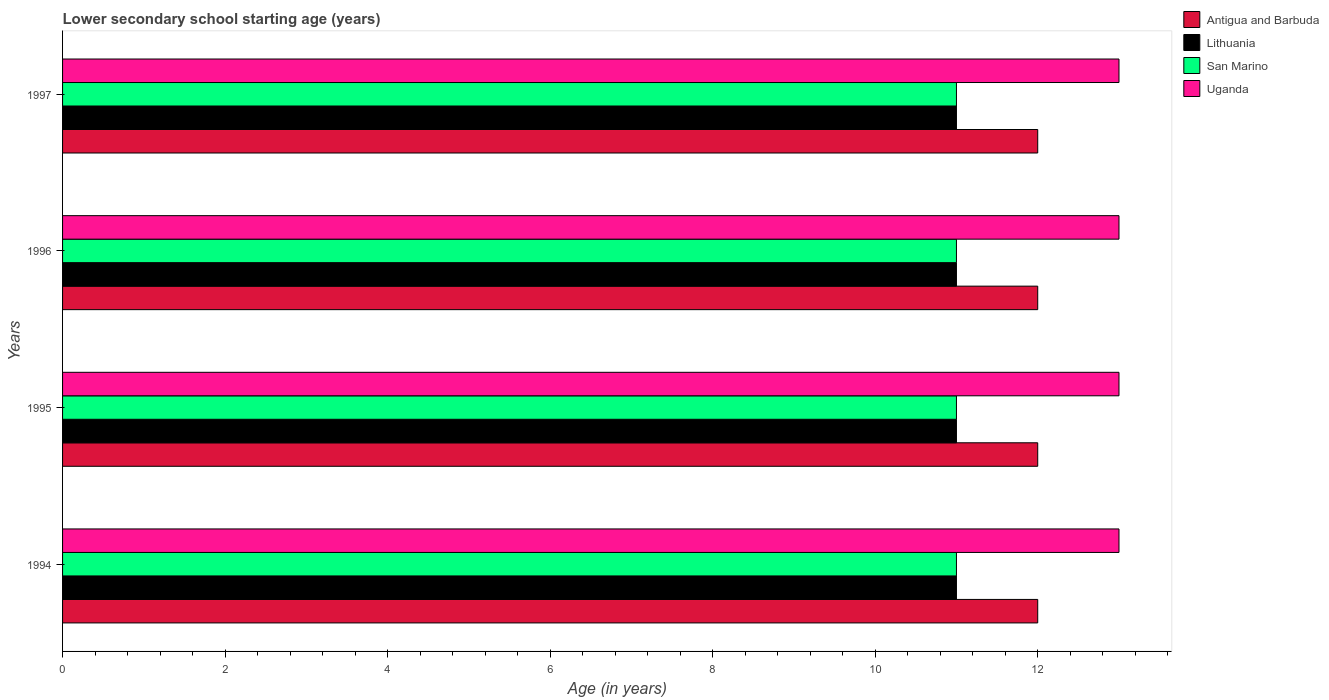How many different coloured bars are there?
Offer a terse response. 4. Are the number of bars on each tick of the Y-axis equal?
Provide a short and direct response. Yes. In how many cases, is the number of bars for a given year not equal to the number of legend labels?
Provide a short and direct response. 0. What is the lower secondary school starting age of children in Uganda in 1995?
Give a very brief answer. 13. Across all years, what is the maximum lower secondary school starting age of children in San Marino?
Provide a succinct answer. 11. Across all years, what is the minimum lower secondary school starting age of children in San Marino?
Provide a succinct answer. 11. What is the total lower secondary school starting age of children in Antigua and Barbuda in the graph?
Make the answer very short. 48. What is the difference between the lower secondary school starting age of children in Uganda in 1997 and the lower secondary school starting age of children in Antigua and Barbuda in 1995?
Offer a very short reply. 1. What is the average lower secondary school starting age of children in Lithuania per year?
Your answer should be very brief. 11. In the year 1994, what is the difference between the lower secondary school starting age of children in San Marino and lower secondary school starting age of children in Antigua and Barbuda?
Provide a succinct answer. -1. In how many years, is the lower secondary school starting age of children in Lithuania greater than 11.6 years?
Offer a very short reply. 0. Is the lower secondary school starting age of children in Lithuania in 1994 less than that in 1997?
Ensure brevity in your answer.  No. Is the difference between the lower secondary school starting age of children in San Marino in 1994 and 1995 greater than the difference between the lower secondary school starting age of children in Antigua and Barbuda in 1994 and 1995?
Give a very brief answer. No. Is the sum of the lower secondary school starting age of children in San Marino in 1995 and 1996 greater than the maximum lower secondary school starting age of children in Uganda across all years?
Make the answer very short. Yes. What does the 1st bar from the top in 1994 represents?
Make the answer very short. Uganda. What does the 3rd bar from the bottom in 1996 represents?
Offer a terse response. San Marino. How many bars are there?
Offer a very short reply. 16. How many years are there in the graph?
Offer a terse response. 4. Are the values on the major ticks of X-axis written in scientific E-notation?
Your answer should be compact. No. Does the graph contain any zero values?
Your response must be concise. No. Where does the legend appear in the graph?
Your answer should be very brief. Top right. What is the title of the graph?
Offer a terse response. Lower secondary school starting age (years). What is the label or title of the X-axis?
Give a very brief answer. Age (in years). What is the Age (in years) of Antigua and Barbuda in 1994?
Your answer should be very brief. 12. What is the Age (in years) of Lithuania in 1994?
Keep it short and to the point. 11. What is the Age (in years) in Uganda in 1995?
Offer a very short reply. 13. What is the Age (in years) of Uganda in 1996?
Provide a succinct answer. 13. What is the Age (in years) of Antigua and Barbuda in 1997?
Provide a short and direct response. 12. What is the Age (in years) in Lithuania in 1997?
Offer a very short reply. 11. What is the Age (in years) in Uganda in 1997?
Your response must be concise. 13. Across all years, what is the maximum Age (in years) of Lithuania?
Keep it short and to the point. 11. Across all years, what is the maximum Age (in years) of San Marino?
Offer a very short reply. 11. Across all years, what is the minimum Age (in years) in Antigua and Barbuda?
Provide a succinct answer. 12. Across all years, what is the minimum Age (in years) in Lithuania?
Keep it short and to the point. 11. Across all years, what is the minimum Age (in years) of Uganda?
Your response must be concise. 13. What is the total Age (in years) of San Marino in the graph?
Your answer should be very brief. 44. What is the difference between the Age (in years) of Lithuania in 1994 and that in 1995?
Your answer should be very brief. 0. What is the difference between the Age (in years) in Uganda in 1994 and that in 1995?
Your response must be concise. 0. What is the difference between the Age (in years) in Antigua and Barbuda in 1994 and that in 1996?
Your response must be concise. 0. What is the difference between the Age (in years) of Lithuania in 1994 and that in 1996?
Ensure brevity in your answer.  0. What is the difference between the Age (in years) in San Marino in 1994 and that in 1997?
Make the answer very short. 0. What is the difference between the Age (in years) of Lithuania in 1995 and that in 1996?
Keep it short and to the point. 0. What is the difference between the Age (in years) of San Marino in 1995 and that in 1996?
Provide a succinct answer. 0. What is the difference between the Age (in years) in Uganda in 1995 and that in 1996?
Provide a short and direct response. 0. What is the difference between the Age (in years) in Lithuania in 1996 and that in 1997?
Provide a succinct answer. 0. What is the difference between the Age (in years) of Uganda in 1996 and that in 1997?
Your response must be concise. 0. What is the difference between the Age (in years) of Antigua and Barbuda in 1994 and the Age (in years) of Lithuania in 1995?
Make the answer very short. 1. What is the difference between the Age (in years) in Antigua and Barbuda in 1994 and the Age (in years) in San Marino in 1995?
Give a very brief answer. 1. What is the difference between the Age (in years) in Antigua and Barbuda in 1994 and the Age (in years) in Uganda in 1995?
Your answer should be compact. -1. What is the difference between the Age (in years) in Lithuania in 1994 and the Age (in years) in Uganda in 1995?
Ensure brevity in your answer.  -2. What is the difference between the Age (in years) in Lithuania in 1994 and the Age (in years) in San Marino in 1996?
Your answer should be compact. 0. What is the difference between the Age (in years) in Lithuania in 1994 and the Age (in years) in Uganda in 1996?
Make the answer very short. -2. What is the difference between the Age (in years) in San Marino in 1994 and the Age (in years) in Uganda in 1996?
Your answer should be very brief. -2. What is the difference between the Age (in years) in Antigua and Barbuda in 1994 and the Age (in years) in Uganda in 1997?
Offer a terse response. -1. What is the difference between the Age (in years) of Lithuania in 1994 and the Age (in years) of Uganda in 1997?
Provide a succinct answer. -2. What is the difference between the Age (in years) of Antigua and Barbuda in 1995 and the Age (in years) of San Marino in 1996?
Provide a succinct answer. 1. What is the difference between the Age (in years) of Antigua and Barbuda in 1995 and the Age (in years) of Uganda in 1996?
Make the answer very short. -1. What is the difference between the Age (in years) in Lithuania in 1995 and the Age (in years) in San Marino in 1996?
Keep it short and to the point. 0. What is the difference between the Age (in years) in San Marino in 1995 and the Age (in years) in Uganda in 1996?
Offer a very short reply. -2. What is the difference between the Age (in years) of Antigua and Barbuda in 1995 and the Age (in years) of Lithuania in 1997?
Your response must be concise. 1. What is the difference between the Age (in years) in Antigua and Barbuda in 1995 and the Age (in years) in San Marino in 1997?
Your answer should be compact. 1. What is the difference between the Age (in years) in Lithuania in 1995 and the Age (in years) in Uganda in 1997?
Offer a terse response. -2. What is the difference between the Age (in years) in San Marino in 1995 and the Age (in years) in Uganda in 1997?
Provide a short and direct response. -2. What is the difference between the Age (in years) of Antigua and Barbuda in 1996 and the Age (in years) of San Marino in 1997?
Provide a short and direct response. 1. What is the difference between the Age (in years) in Antigua and Barbuda in 1996 and the Age (in years) in Uganda in 1997?
Your answer should be very brief. -1. What is the difference between the Age (in years) of Lithuania in 1996 and the Age (in years) of San Marino in 1997?
Make the answer very short. 0. What is the difference between the Age (in years) of Lithuania in 1996 and the Age (in years) of Uganda in 1997?
Give a very brief answer. -2. What is the difference between the Age (in years) of San Marino in 1996 and the Age (in years) of Uganda in 1997?
Provide a succinct answer. -2. What is the average Age (in years) in Lithuania per year?
Offer a terse response. 11. What is the average Age (in years) of San Marino per year?
Ensure brevity in your answer.  11. What is the average Age (in years) in Uganda per year?
Offer a terse response. 13. In the year 1994, what is the difference between the Age (in years) of Antigua and Barbuda and Age (in years) of Lithuania?
Provide a short and direct response. 1. In the year 1994, what is the difference between the Age (in years) in Antigua and Barbuda and Age (in years) in San Marino?
Give a very brief answer. 1. In the year 1994, what is the difference between the Age (in years) in Lithuania and Age (in years) in San Marino?
Your answer should be very brief. 0. In the year 1994, what is the difference between the Age (in years) in San Marino and Age (in years) in Uganda?
Make the answer very short. -2. In the year 1995, what is the difference between the Age (in years) in Antigua and Barbuda and Age (in years) in Lithuania?
Provide a short and direct response. 1. In the year 1995, what is the difference between the Age (in years) in Antigua and Barbuda and Age (in years) in San Marino?
Your answer should be compact. 1. In the year 1995, what is the difference between the Age (in years) in Lithuania and Age (in years) in San Marino?
Your answer should be very brief. 0. In the year 1995, what is the difference between the Age (in years) of San Marino and Age (in years) of Uganda?
Your answer should be very brief. -2. In the year 1996, what is the difference between the Age (in years) of Antigua and Barbuda and Age (in years) of Lithuania?
Give a very brief answer. 1. In the year 1996, what is the difference between the Age (in years) in Lithuania and Age (in years) in San Marino?
Provide a short and direct response. 0. In the year 1996, what is the difference between the Age (in years) of Lithuania and Age (in years) of Uganda?
Your response must be concise. -2. In the year 1996, what is the difference between the Age (in years) in San Marino and Age (in years) in Uganda?
Provide a short and direct response. -2. In the year 1997, what is the difference between the Age (in years) of Antigua and Barbuda and Age (in years) of Lithuania?
Ensure brevity in your answer.  1. In the year 1997, what is the difference between the Age (in years) of Antigua and Barbuda and Age (in years) of San Marino?
Offer a terse response. 1. In the year 1997, what is the difference between the Age (in years) of Lithuania and Age (in years) of Uganda?
Keep it short and to the point. -2. What is the ratio of the Age (in years) of San Marino in 1994 to that in 1995?
Make the answer very short. 1. What is the ratio of the Age (in years) in Lithuania in 1994 to that in 1996?
Provide a short and direct response. 1. What is the ratio of the Age (in years) of San Marino in 1994 to that in 1996?
Provide a succinct answer. 1. What is the ratio of the Age (in years) in Uganda in 1994 to that in 1996?
Offer a terse response. 1. What is the ratio of the Age (in years) of Antigua and Barbuda in 1994 to that in 1997?
Keep it short and to the point. 1. What is the ratio of the Age (in years) in Lithuania in 1994 to that in 1997?
Offer a very short reply. 1. What is the ratio of the Age (in years) of San Marino in 1994 to that in 1997?
Provide a short and direct response. 1. What is the ratio of the Age (in years) of Antigua and Barbuda in 1995 to that in 1996?
Your response must be concise. 1. What is the ratio of the Age (in years) of San Marino in 1995 to that in 1996?
Your response must be concise. 1. What is the ratio of the Age (in years) in Antigua and Barbuda in 1995 to that in 1997?
Make the answer very short. 1. What is the ratio of the Age (in years) of Lithuania in 1995 to that in 1997?
Provide a succinct answer. 1. What is the ratio of the Age (in years) in San Marino in 1995 to that in 1997?
Offer a terse response. 1. What is the difference between the highest and the second highest Age (in years) of Antigua and Barbuda?
Give a very brief answer. 0. What is the difference between the highest and the second highest Age (in years) of Lithuania?
Your answer should be very brief. 0. What is the difference between the highest and the second highest Age (in years) of San Marino?
Offer a very short reply. 0. What is the difference between the highest and the second highest Age (in years) of Uganda?
Provide a succinct answer. 0. What is the difference between the highest and the lowest Age (in years) in Antigua and Barbuda?
Your answer should be compact. 0. What is the difference between the highest and the lowest Age (in years) in Lithuania?
Provide a succinct answer. 0. 